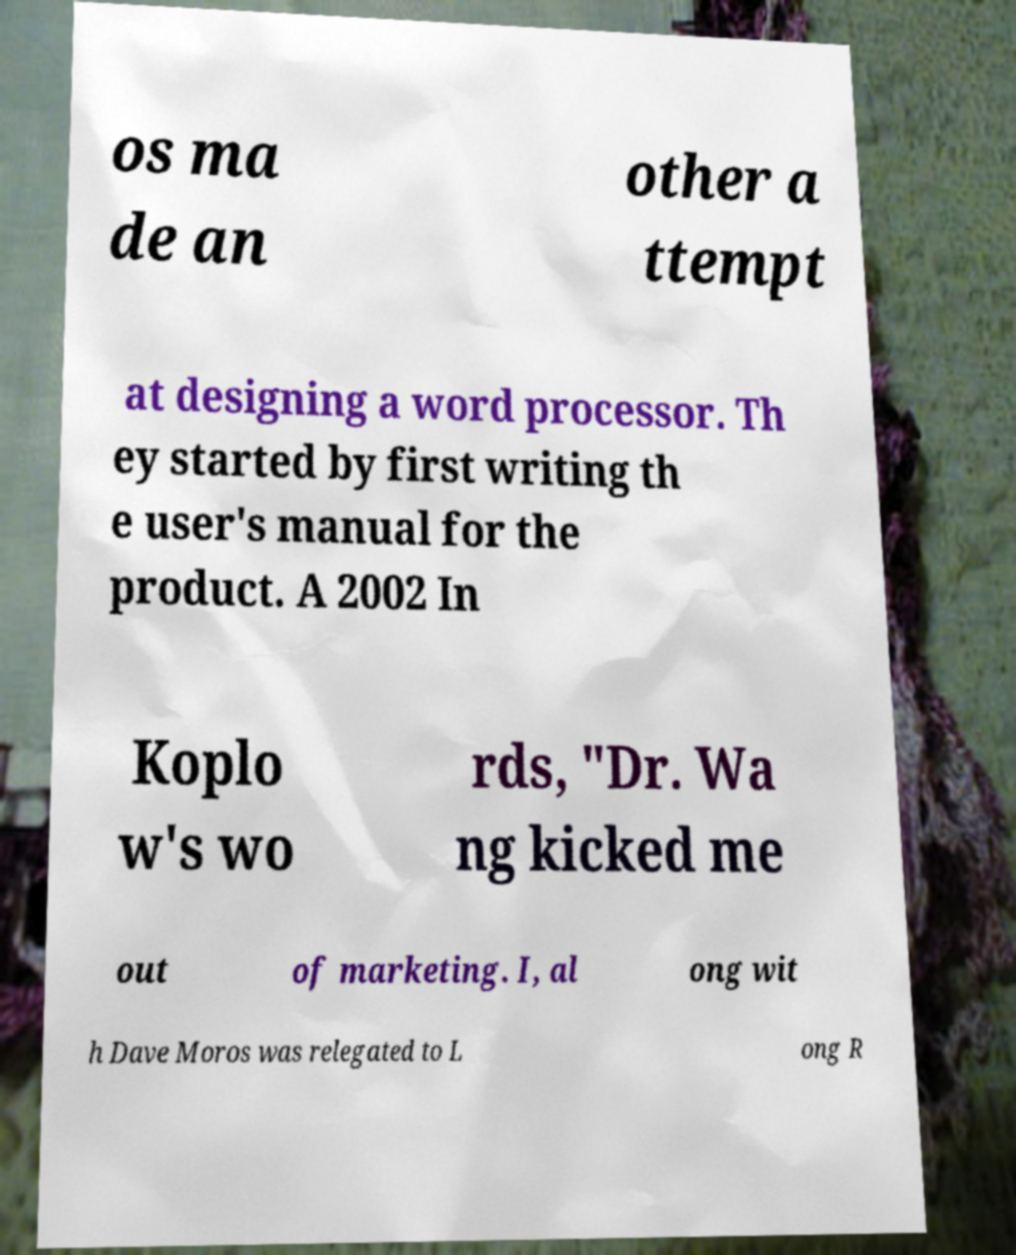Can you read and provide the text displayed in the image?This photo seems to have some interesting text. Can you extract and type it out for me? os ma de an other a ttempt at designing a word processor. Th ey started by first writing th e user's manual for the product. A 2002 In Koplo w's wo rds, "Dr. Wa ng kicked me out of marketing. I, al ong wit h Dave Moros was relegated to L ong R 